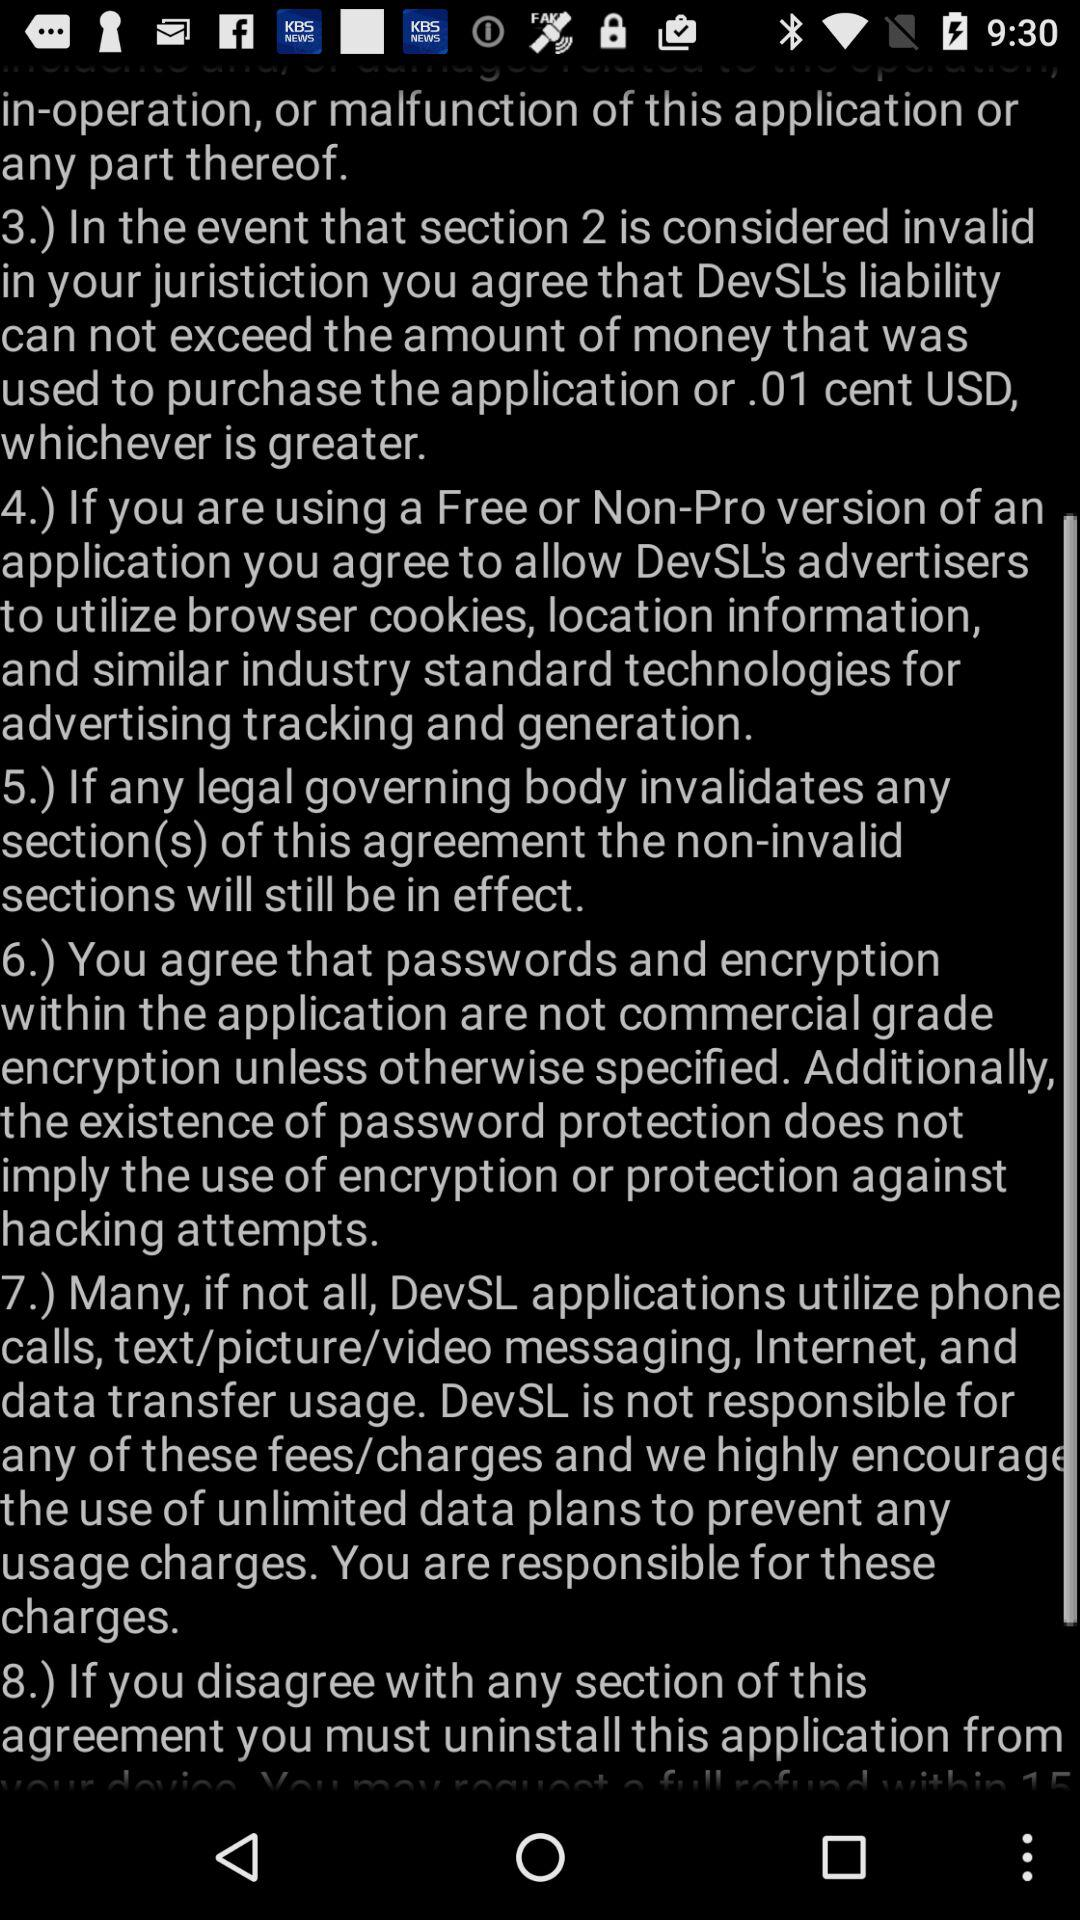What information does section 4 of the agreement pertain to? Section 4 of the agreement specifies that if a user is utilizing a Free or Non-Pro version of an application, they must agree to allow the application's advertisers to use browser cookies, location information, and similar industry-standard technologies for advertising tracking and generation. Are there any provisions about data usage in the agreement? Yes, section 7 of the agreement discusses data usage. It mentions that DevSL applications may utilize phone calls, text/picture/video messaging, and internet data transfer, and clarifies that DevSL is not responsible for any related fees or charges. It also encourages the use of unlimited data plans to avoid unexpected usage charges. 